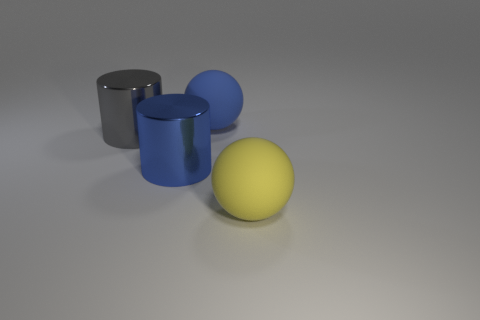There is a large matte sphere that is behind the gray metal object; does it have the same color as the large matte sphere that is in front of the gray cylinder?
Make the answer very short. No. What is the material of the large sphere that is behind the big blue metallic cylinder?
Your response must be concise. Rubber. There is a cylinder that is made of the same material as the large gray thing; what color is it?
Keep it short and to the point. Blue. How many green spheres are the same size as the blue cylinder?
Ensure brevity in your answer.  0. Is the size of the blue thing that is in front of the gray cylinder the same as the large yellow sphere?
Your answer should be very brief. Yes. There is a thing that is both right of the large blue metallic thing and behind the big yellow object; what shape is it?
Offer a very short reply. Sphere. Are there any large blue cylinders left of the blue sphere?
Ensure brevity in your answer.  Yes. Are there any other things that have the same shape as the big yellow object?
Ensure brevity in your answer.  Yes. Do the large blue shiny object and the large gray metallic thing have the same shape?
Your answer should be compact. Yes. Is the number of blue things that are on the right side of the blue metallic object the same as the number of large objects behind the large blue matte thing?
Offer a terse response. No. 